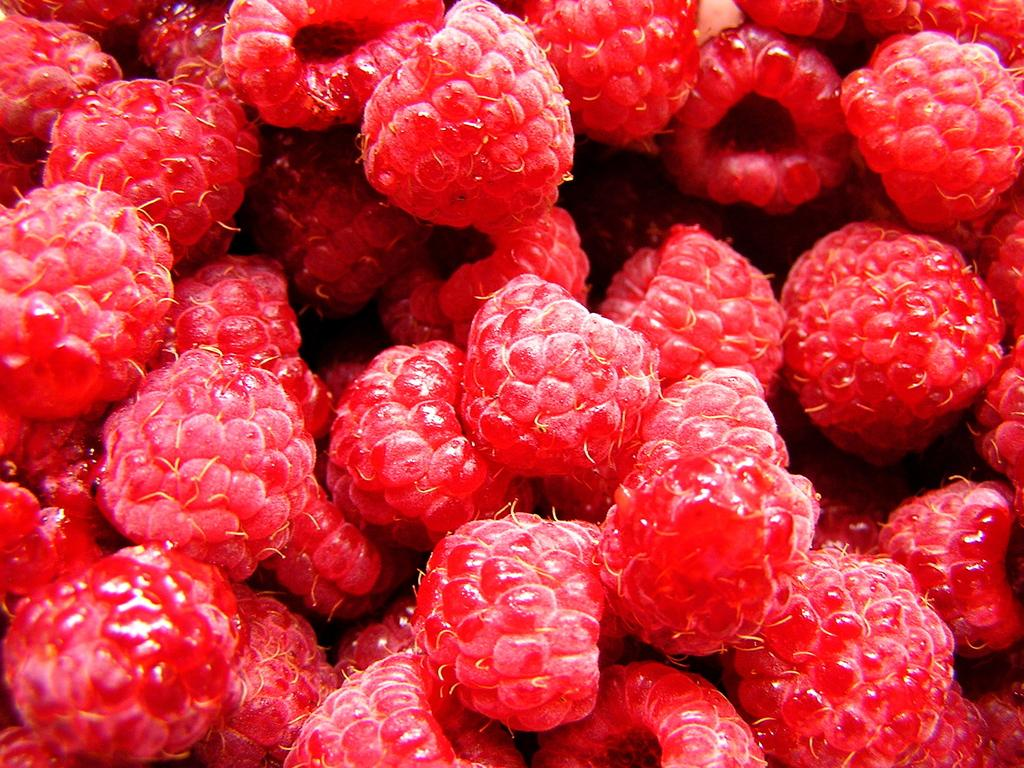What type of fruit is present in the image? There are raspberries in the image. Can you hear the goose laughing in the image? There is no goose or laughter present in the image; it only features raspberries. 